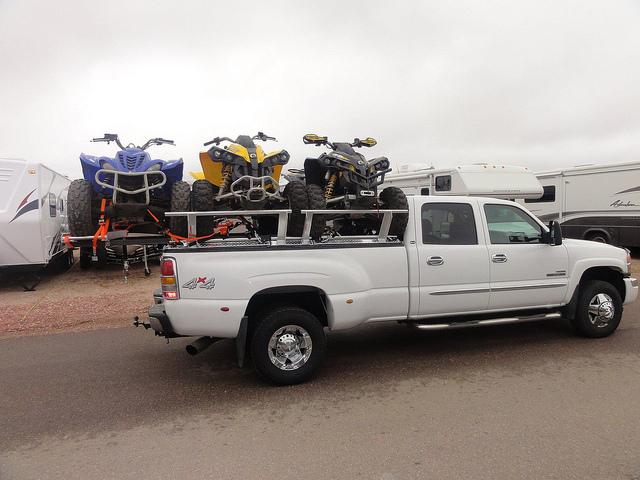What kind of vehicles are in the background?
Short answer required. 4 wheelers. What is the main color of the truck?
Short answer required. White. What kind of truck is this?
Keep it brief. Pickup. What is in the back of this truck?
Answer briefly. Atv. What color is the truck?
Quick response, please. White. How many vehicles in picture are white?
Be succinct. 4. How many four wheelers are there?
Give a very brief answer. 3. Is this a parking lot?
Be succinct. No. What is cast?
Write a very short answer. Sky. Where is a silver ladder?
Keep it brief. Truck. How many vehicles are shown?
Concise answer only. 7. Why does the truck have orange flags on it?
Concise answer only. Represents country. What is the truck hauling?
Be succinct. Atvs. Is the truck moving?
Concise answer only. No. 